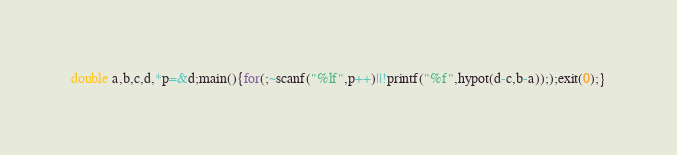<code> <loc_0><loc_0><loc_500><loc_500><_C_>double a,b,c,d,*p=&d;main(){for(;~scanf("%lf",p++)||!printf("%f",hypot(d-c,b-a)););exit(0);}</code> 